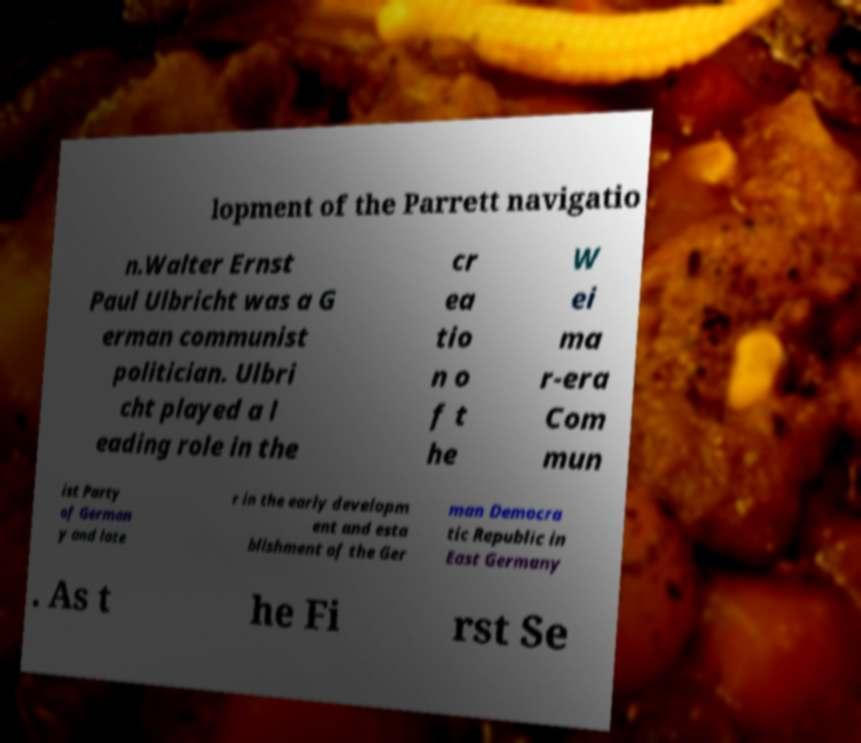For documentation purposes, I need the text within this image transcribed. Could you provide that? lopment of the Parrett navigatio n.Walter Ernst Paul Ulbricht was a G erman communist politician. Ulbri cht played a l eading role in the cr ea tio n o f t he W ei ma r-era Com mun ist Party of German y and late r in the early developm ent and esta blishment of the Ger man Democra tic Republic in East Germany . As t he Fi rst Se 